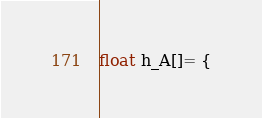<code> <loc_0><loc_0><loc_500><loc_500><_Cuda_>float h_A[]= {</code> 